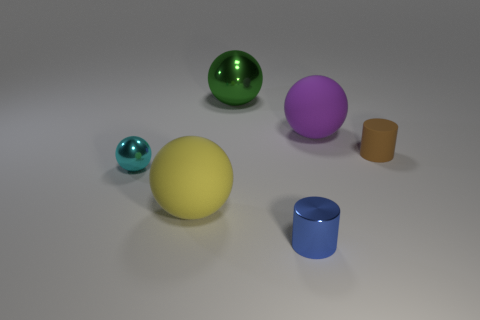There is a rubber object in front of the tiny object that is on the left side of the metallic sphere that is behind the purple object; what shape is it?
Make the answer very short. Sphere. What number of other objects are there of the same shape as the green thing?
Ensure brevity in your answer.  3. What color is the metal cylinder that is the same size as the cyan ball?
Your answer should be very brief. Blue. How many cubes are small rubber objects or big yellow matte things?
Make the answer very short. 0. What number of rubber balls are there?
Offer a terse response. 2. Is the shape of the brown matte object the same as the object behind the big purple matte object?
Keep it short and to the point. No. What number of objects are big spheres or green spheres?
Ensure brevity in your answer.  3. What is the shape of the big rubber thing that is behind the matte object that is on the left side of the big green thing?
Offer a very short reply. Sphere. There is a tiny thing to the left of the green object; does it have the same shape as the brown matte object?
Offer a terse response. No. There is a green object that is made of the same material as the small blue cylinder; what is its size?
Your answer should be very brief. Large. 